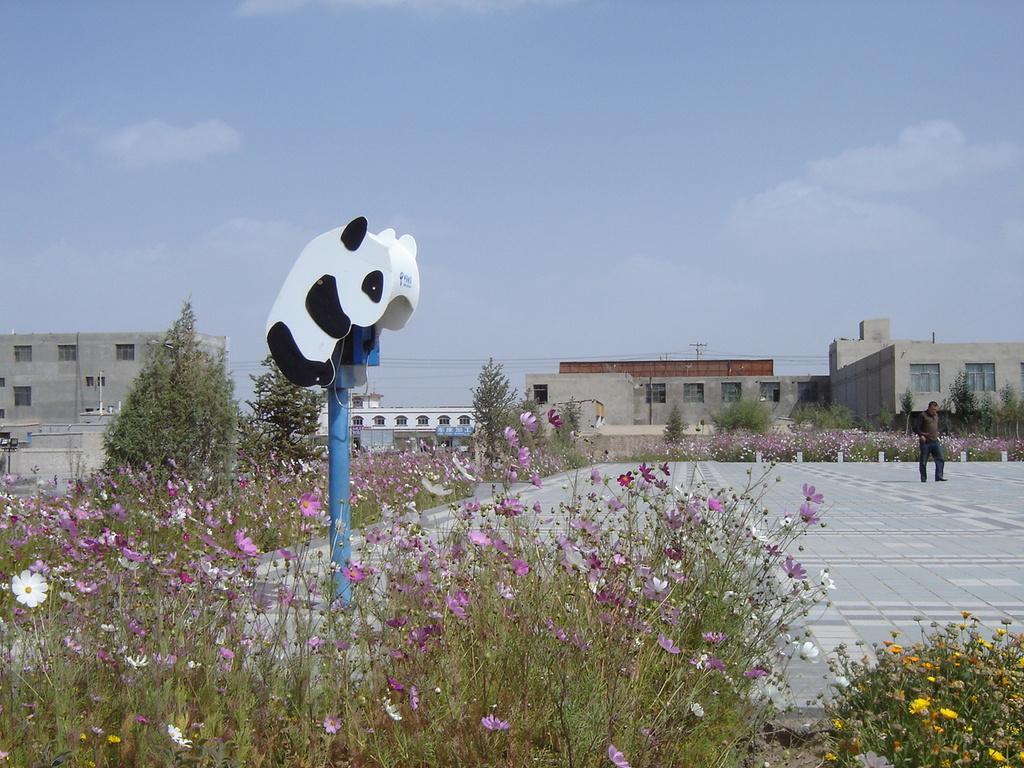How would you summarize this image in a sentence or two? In this picture we can see flowers, pole, buildings with windows, wires and a man walking on the ground and in the background we can see the sky with clouds. 